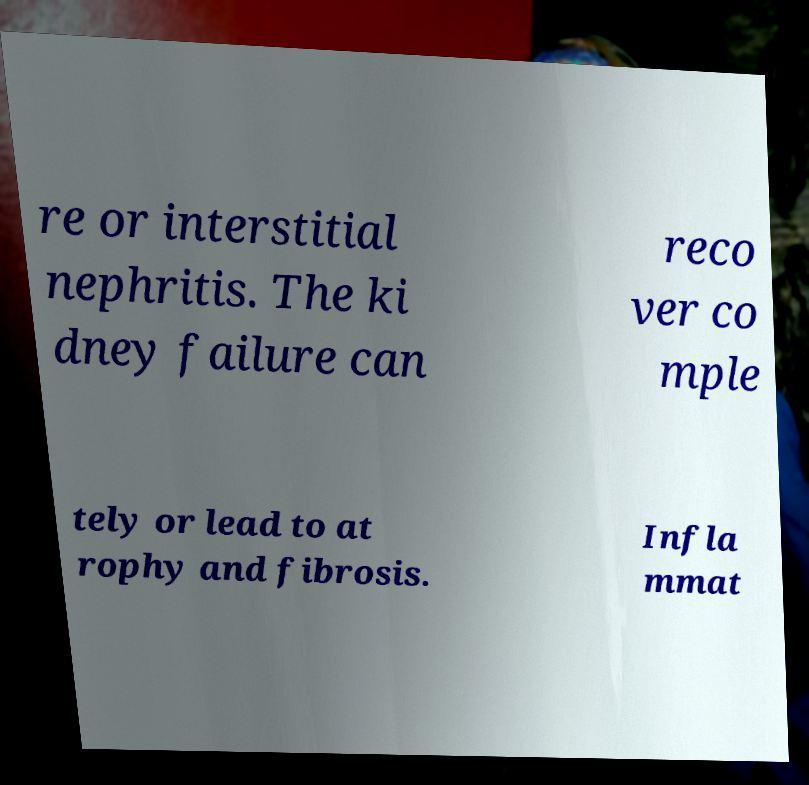For documentation purposes, I need the text within this image transcribed. Could you provide that? re or interstitial nephritis. The ki dney failure can reco ver co mple tely or lead to at rophy and fibrosis. Infla mmat 